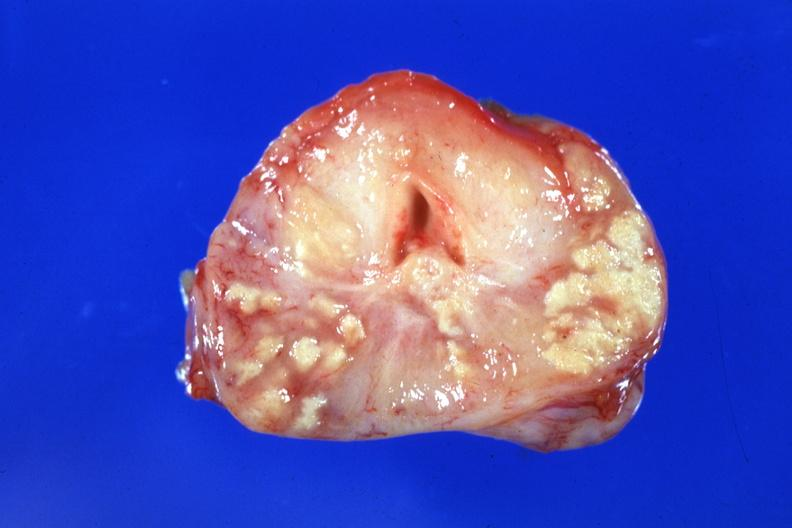how is large caseous lesions seen example?
Answer the question using a single word or phrase. Excellent 